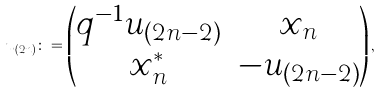Convert formula to latex. <formula><loc_0><loc_0><loc_500><loc_500>u _ { ( 2 n ) } \colon = \begin{pmatrix} q ^ { - 1 } u _ { ( 2 n - 2 ) } & x _ { n } \\ x _ { n } ^ { * } & - u _ { ( 2 n - 2 ) } \end{pmatrix} ,</formula> 